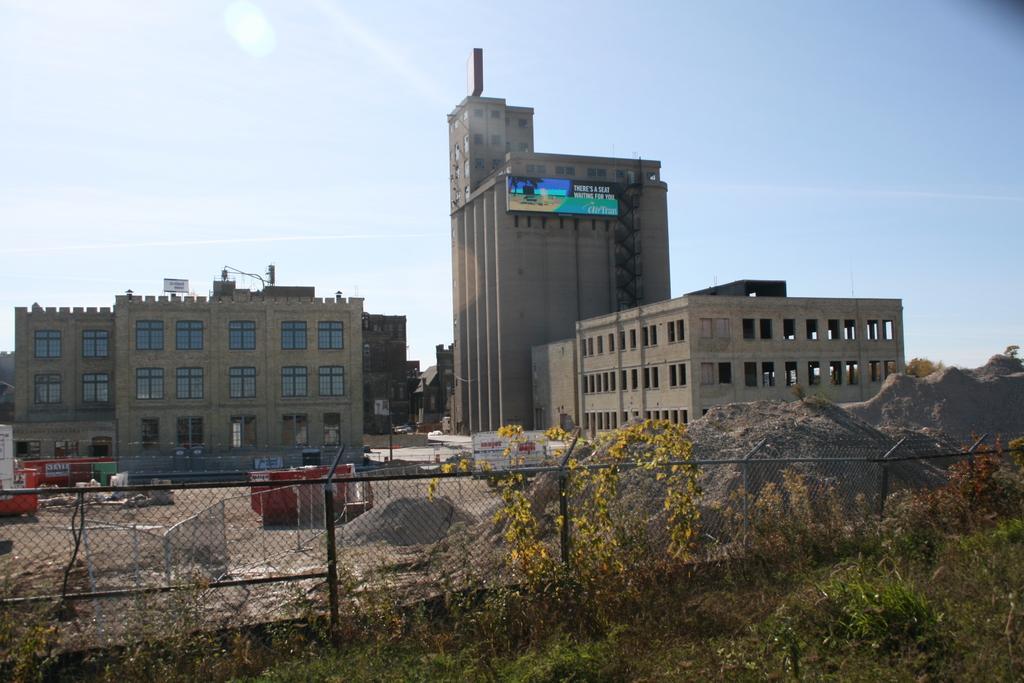Please provide a concise description of this image. In this picture we can see few plants and some fencing from left to right. We can see some vehicles on the path. There is some sand on the right side. We can see few buildings, poles and a board on the building. 